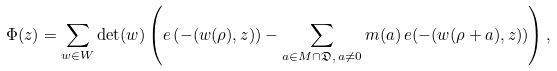Convert formula to latex. <formula><loc_0><loc_0><loc_500><loc_500>\Phi ( z ) = \sum _ { w \in W } \det ( w ) \left ( e \left ( - ( w ( \rho ) , z ) \right ) - \sum _ { a \in M \cap \mathfrak D , \, a \ne 0 } m ( a ) \, e ( - ( w ( \rho + a ) , z ) ) \right ) ,</formula> 